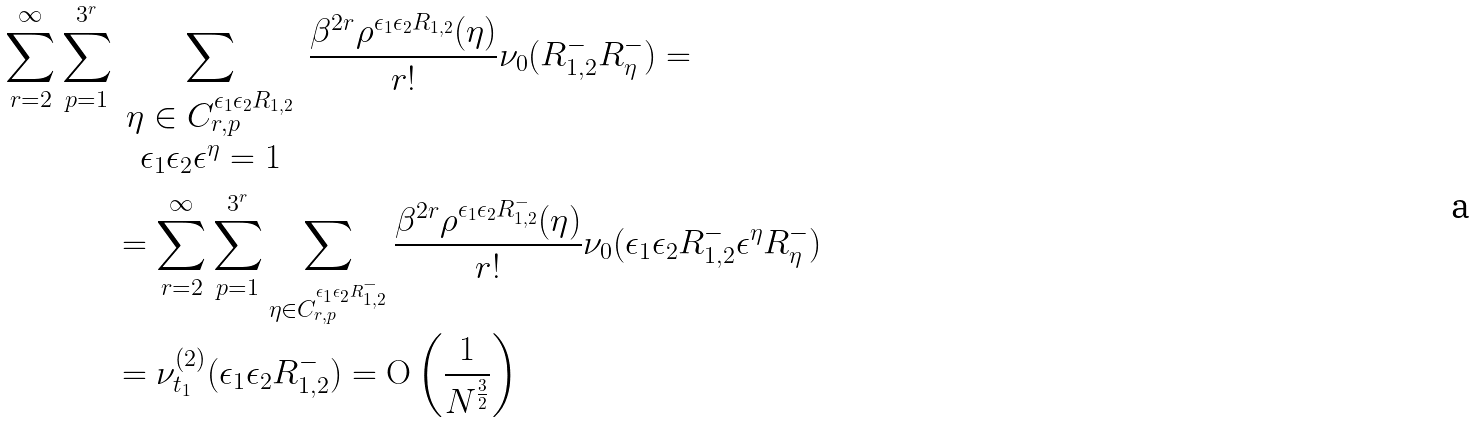Convert formula to latex. <formula><loc_0><loc_0><loc_500><loc_500>\sum _ { r = 2 } ^ { \infty } \sum _ { p = 1 } ^ { 3 ^ { r } } & \sum _ { \begin{array} { c } \eta \in C ^ { \epsilon _ { 1 } \epsilon _ { 2 } R _ { 1 , 2 } } _ { r , p } \\ \epsilon _ { 1 } \epsilon _ { 2 } \epsilon ^ { \eta } = 1 \end{array} } \frac { \beta ^ { 2 r } \rho ^ { \epsilon _ { 1 } \epsilon _ { 2 } R _ { 1 , 2 } } ( \eta ) } { r ! } \nu _ { 0 } ( R _ { 1 , 2 } ^ { - } R ^ { - } _ { \eta } ) = \\ & = \sum _ { r = 2 } ^ { \infty } \sum _ { p = 1 } ^ { 3 ^ { r } } \sum _ { \eta \in C _ { r , p } ^ { \epsilon _ { 1 } \epsilon _ { 2 } R _ { 1 , 2 } ^ { - } } } \frac { \beta ^ { 2 r } \rho ^ { \epsilon _ { 1 } \epsilon _ { 2 } R _ { 1 , 2 } ^ { - } } ( \eta ) } { r ! } \nu _ { 0 } ( \epsilon _ { 1 } \epsilon _ { 2 } R ^ { - } _ { 1 , 2 } \epsilon ^ { \eta } R _ { \eta } ^ { - } ) \\ & = \nu _ { t _ { 1 } } ^ { ( 2 ) } ( \epsilon _ { 1 } \epsilon _ { 2 } R _ { 1 , 2 } ^ { - } ) = \mathrm O \left ( \frac { 1 } { N ^ { \frac { 3 } { 2 } } } \right )</formula> 